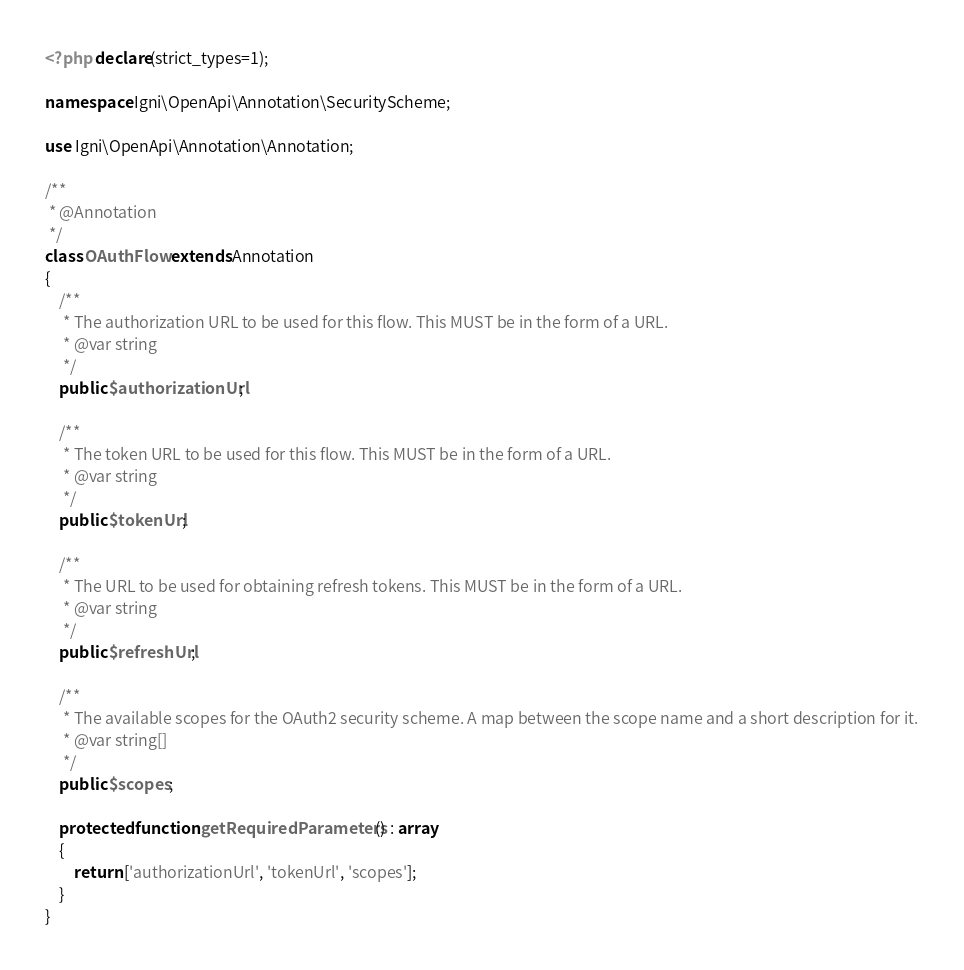Convert code to text. <code><loc_0><loc_0><loc_500><loc_500><_PHP_><?php declare(strict_types=1);

namespace Igni\OpenApi\Annotation\SecurityScheme;

use Igni\OpenApi\Annotation\Annotation;

/**
 * @Annotation
 */
class OAuthFlow extends Annotation
{
    /**
     * The authorization URL to be used for this flow. This MUST be in the form of a URL.
     * @var string
     */
    public $authorizationUrl;

    /**
     * The token URL to be used for this flow. This MUST be in the form of a URL.
     * @var string
     */
    public $tokenUrl;

    /**
     * The URL to be used for obtaining refresh tokens. This MUST be in the form of a URL.
     * @var string
     */
    public $refreshUrl;

    /**
     * The available scopes for the OAuth2 security scheme. A map between the scope name and a short description for it.
     * @var string[]
     */
    public $scopes;

    protected function getRequiredParameters() : array
    {
        return ['authorizationUrl', 'tokenUrl', 'scopes'];
    }
}</code> 